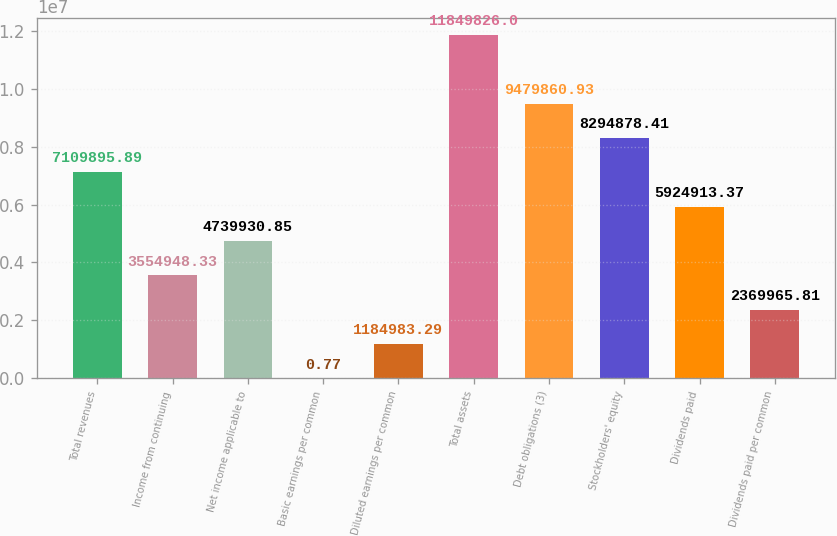<chart> <loc_0><loc_0><loc_500><loc_500><bar_chart><fcel>Total revenues<fcel>Income from continuing<fcel>Net income applicable to<fcel>Basic earnings per common<fcel>Diluted earnings per common<fcel>Total assets<fcel>Debt obligations (3)<fcel>Stockholders' equity<fcel>Dividends paid<fcel>Dividends paid per common<nl><fcel>7.1099e+06<fcel>3.55495e+06<fcel>4.73993e+06<fcel>0.77<fcel>1.18498e+06<fcel>1.18498e+07<fcel>9.47986e+06<fcel>8.29488e+06<fcel>5.92491e+06<fcel>2.36997e+06<nl></chart> 